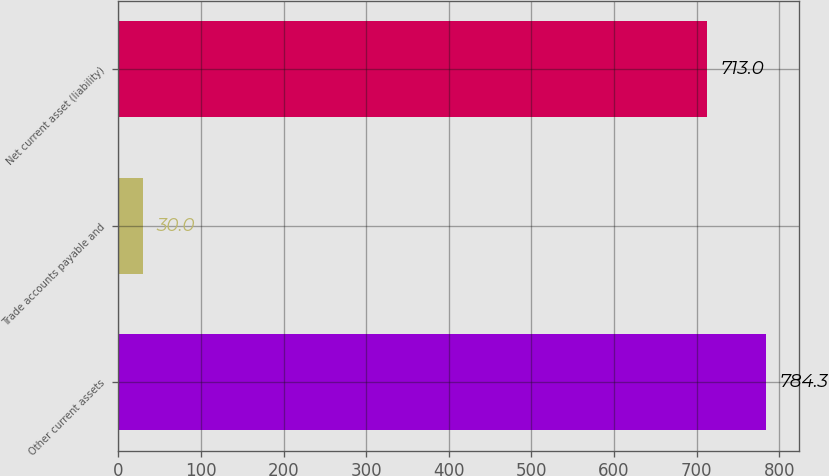Convert chart to OTSL. <chart><loc_0><loc_0><loc_500><loc_500><bar_chart><fcel>Other current assets<fcel>Trade accounts payable and<fcel>Net current asset (liability)<nl><fcel>784.3<fcel>30<fcel>713<nl></chart> 